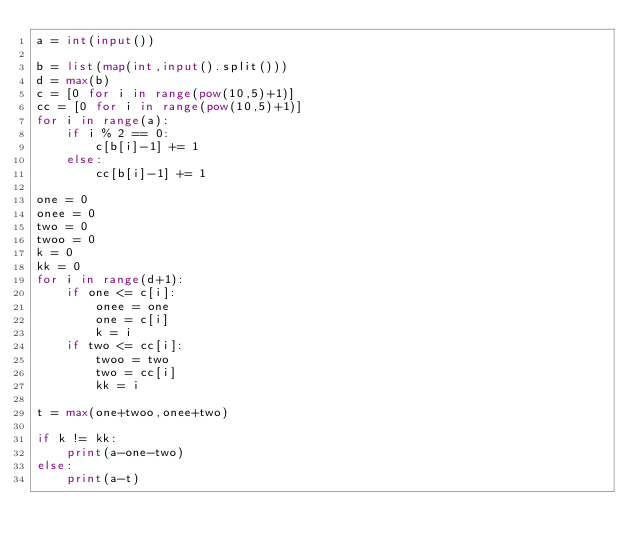Convert code to text. <code><loc_0><loc_0><loc_500><loc_500><_Python_>a = int(input())

b = list(map(int,input().split()))
d = max(b)
c = [0 for i in range(pow(10,5)+1)]
cc = [0 for i in range(pow(10,5)+1)]
for i in range(a):
    if i % 2 == 0:
        c[b[i]-1] += 1
    else:
        cc[b[i]-1] += 1

one = 0
onee = 0
two = 0
twoo = 0
k = 0
kk = 0
for i in range(d+1):
    if one <= c[i]:
        onee = one
        one = c[i]
        k = i
    if two <= cc[i]:
        twoo = two
        two = cc[i]
        kk = i

t = max(one+twoo,onee+two)

if k != kk:
    print(a-one-two)
else:
    print(a-t)</code> 